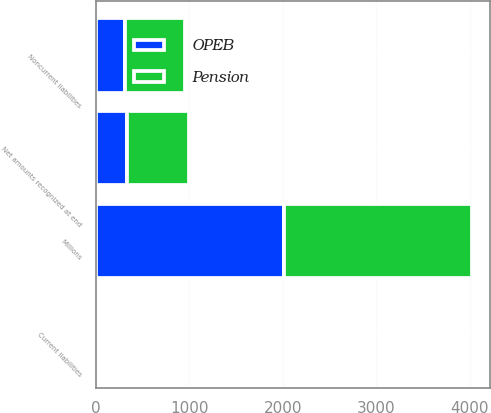Convert chart to OTSL. <chart><loc_0><loc_0><loc_500><loc_500><stacked_bar_chart><ecel><fcel>Millions<fcel>Current liabilities<fcel>Noncurrent liabilities<fcel>Net amounts recognized at end<nl><fcel>Pension<fcel>2011<fcel>15<fcel>645<fcel>660<nl><fcel>OPEB<fcel>2011<fcel>26<fcel>310<fcel>336<nl></chart> 